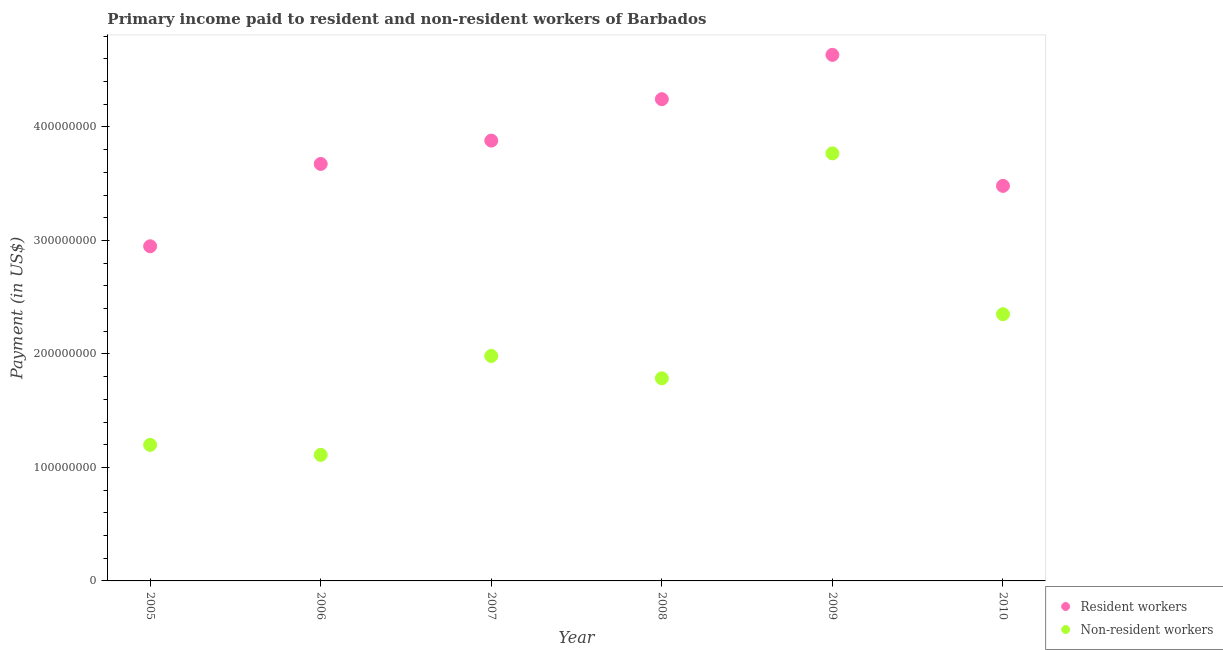What is the payment made to non-resident workers in 2005?
Offer a very short reply. 1.20e+08. Across all years, what is the maximum payment made to non-resident workers?
Your answer should be very brief. 3.77e+08. Across all years, what is the minimum payment made to non-resident workers?
Provide a succinct answer. 1.11e+08. In which year was the payment made to non-resident workers maximum?
Offer a very short reply. 2009. What is the total payment made to non-resident workers in the graph?
Offer a very short reply. 1.22e+09. What is the difference between the payment made to resident workers in 2005 and that in 2010?
Your response must be concise. -5.32e+07. What is the difference between the payment made to resident workers in 2010 and the payment made to non-resident workers in 2008?
Your answer should be very brief. 1.70e+08. What is the average payment made to non-resident workers per year?
Ensure brevity in your answer.  2.03e+08. In the year 2010, what is the difference between the payment made to non-resident workers and payment made to resident workers?
Provide a succinct answer. -1.13e+08. What is the ratio of the payment made to resident workers in 2006 to that in 2008?
Keep it short and to the point. 0.87. Is the difference between the payment made to non-resident workers in 2009 and 2010 greater than the difference between the payment made to resident workers in 2009 and 2010?
Offer a very short reply. Yes. What is the difference between the highest and the second highest payment made to non-resident workers?
Ensure brevity in your answer.  1.42e+08. What is the difference between the highest and the lowest payment made to resident workers?
Ensure brevity in your answer.  1.69e+08. In how many years, is the payment made to resident workers greater than the average payment made to resident workers taken over all years?
Your answer should be very brief. 3. Does the payment made to resident workers monotonically increase over the years?
Your response must be concise. No. Is the payment made to resident workers strictly greater than the payment made to non-resident workers over the years?
Keep it short and to the point. Yes. Is the payment made to non-resident workers strictly less than the payment made to resident workers over the years?
Keep it short and to the point. Yes. How many dotlines are there?
Your answer should be compact. 2. How many years are there in the graph?
Your response must be concise. 6. What is the difference between two consecutive major ticks on the Y-axis?
Your answer should be very brief. 1.00e+08. Does the graph contain any zero values?
Keep it short and to the point. No. Does the graph contain grids?
Your answer should be compact. No. Where does the legend appear in the graph?
Your answer should be very brief. Bottom right. What is the title of the graph?
Your response must be concise. Primary income paid to resident and non-resident workers of Barbados. Does "Male labourers" appear as one of the legend labels in the graph?
Your response must be concise. No. What is the label or title of the Y-axis?
Keep it short and to the point. Payment (in US$). What is the Payment (in US$) in Resident workers in 2005?
Provide a short and direct response. 2.95e+08. What is the Payment (in US$) in Non-resident workers in 2005?
Provide a short and direct response. 1.20e+08. What is the Payment (in US$) of Resident workers in 2006?
Ensure brevity in your answer.  3.67e+08. What is the Payment (in US$) in Non-resident workers in 2006?
Your answer should be compact. 1.11e+08. What is the Payment (in US$) in Resident workers in 2007?
Ensure brevity in your answer.  3.88e+08. What is the Payment (in US$) of Non-resident workers in 2007?
Your answer should be compact. 1.98e+08. What is the Payment (in US$) of Resident workers in 2008?
Your answer should be very brief. 4.25e+08. What is the Payment (in US$) in Non-resident workers in 2008?
Provide a short and direct response. 1.79e+08. What is the Payment (in US$) in Resident workers in 2009?
Offer a terse response. 4.64e+08. What is the Payment (in US$) in Non-resident workers in 2009?
Give a very brief answer. 3.77e+08. What is the Payment (in US$) of Resident workers in 2010?
Your response must be concise. 3.48e+08. What is the Payment (in US$) of Non-resident workers in 2010?
Give a very brief answer. 2.35e+08. Across all years, what is the maximum Payment (in US$) of Resident workers?
Keep it short and to the point. 4.64e+08. Across all years, what is the maximum Payment (in US$) of Non-resident workers?
Your answer should be compact. 3.77e+08. Across all years, what is the minimum Payment (in US$) in Resident workers?
Make the answer very short. 2.95e+08. Across all years, what is the minimum Payment (in US$) in Non-resident workers?
Provide a succinct answer. 1.11e+08. What is the total Payment (in US$) of Resident workers in the graph?
Your answer should be very brief. 2.29e+09. What is the total Payment (in US$) in Non-resident workers in the graph?
Keep it short and to the point. 1.22e+09. What is the difference between the Payment (in US$) of Resident workers in 2005 and that in 2006?
Offer a very short reply. -7.26e+07. What is the difference between the Payment (in US$) of Non-resident workers in 2005 and that in 2006?
Give a very brief answer. 8.82e+06. What is the difference between the Payment (in US$) of Resident workers in 2005 and that in 2007?
Your answer should be compact. -9.31e+07. What is the difference between the Payment (in US$) of Non-resident workers in 2005 and that in 2007?
Provide a short and direct response. -7.84e+07. What is the difference between the Payment (in US$) in Resident workers in 2005 and that in 2008?
Keep it short and to the point. -1.30e+08. What is the difference between the Payment (in US$) of Non-resident workers in 2005 and that in 2008?
Provide a short and direct response. -5.87e+07. What is the difference between the Payment (in US$) in Resident workers in 2005 and that in 2009?
Your response must be concise. -1.69e+08. What is the difference between the Payment (in US$) of Non-resident workers in 2005 and that in 2009?
Your answer should be compact. -2.57e+08. What is the difference between the Payment (in US$) in Resident workers in 2005 and that in 2010?
Offer a terse response. -5.32e+07. What is the difference between the Payment (in US$) of Non-resident workers in 2005 and that in 2010?
Offer a very short reply. -1.15e+08. What is the difference between the Payment (in US$) in Resident workers in 2006 and that in 2007?
Offer a very short reply. -2.06e+07. What is the difference between the Payment (in US$) in Non-resident workers in 2006 and that in 2007?
Ensure brevity in your answer.  -8.72e+07. What is the difference between the Payment (in US$) of Resident workers in 2006 and that in 2008?
Provide a succinct answer. -5.71e+07. What is the difference between the Payment (in US$) in Non-resident workers in 2006 and that in 2008?
Give a very brief answer. -6.75e+07. What is the difference between the Payment (in US$) of Resident workers in 2006 and that in 2009?
Your response must be concise. -9.61e+07. What is the difference between the Payment (in US$) of Non-resident workers in 2006 and that in 2009?
Make the answer very short. -2.66e+08. What is the difference between the Payment (in US$) of Resident workers in 2006 and that in 2010?
Keep it short and to the point. 1.93e+07. What is the difference between the Payment (in US$) in Non-resident workers in 2006 and that in 2010?
Your response must be concise. -1.24e+08. What is the difference between the Payment (in US$) of Resident workers in 2007 and that in 2008?
Your answer should be very brief. -3.65e+07. What is the difference between the Payment (in US$) of Non-resident workers in 2007 and that in 2008?
Your answer should be compact. 1.97e+07. What is the difference between the Payment (in US$) in Resident workers in 2007 and that in 2009?
Your answer should be very brief. -7.56e+07. What is the difference between the Payment (in US$) of Non-resident workers in 2007 and that in 2009?
Keep it short and to the point. -1.78e+08. What is the difference between the Payment (in US$) in Resident workers in 2007 and that in 2010?
Provide a short and direct response. 3.99e+07. What is the difference between the Payment (in US$) of Non-resident workers in 2007 and that in 2010?
Provide a short and direct response. -3.68e+07. What is the difference between the Payment (in US$) of Resident workers in 2008 and that in 2009?
Offer a terse response. -3.90e+07. What is the difference between the Payment (in US$) in Non-resident workers in 2008 and that in 2009?
Your answer should be very brief. -1.98e+08. What is the difference between the Payment (in US$) in Resident workers in 2008 and that in 2010?
Your response must be concise. 7.64e+07. What is the difference between the Payment (in US$) of Non-resident workers in 2008 and that in 2010?
Keep it short and to the point. -5.65e+07. What is the difference between the Payment (in US$) of Resident workers in 2009 and that in 2010?
Give a very brief answer. 1.15e+08. What is the difference between the Payment (in US$) in Non-resident workers in 2009 and that in 2010?
Make the answer very short. 1.42e+08. What is the difference between the Payment (in US$) of Resident workers in 2005 and the Payment (in US$) of Non-resident workers in 2006?
Offer a very short reply. 1.84e+08. What is the difference between the Payment (in US$) of Resident workers in 2005 and the Payment (in US$) of Non-resident workers in 2007?
Your answer should be very brief. 9.66e+07. What is the difference between the Payment (in US$) of Resident workers in 2005 and the Payment (in US$) of Non-resident workers in 2008?
Ensure brevity in your answer.  1.16e+08. What is the difference between the Payment (in US$) of Resident workers in 2005 and the Payment (in US$) of Non-resident workers in 2009?
Give a very brief answer. -8.19e+07. What is the difference between the Payment (in US$) of Resident workers in 2005 and the Payment (in US$) of Non-resident workers in 2010?
Your response must be concise. 5.99e+07. What is the difference between the Payment (in US$) of Resident workers in 2006 and the Payment (in US$) of Non-resident workers in 2007?
Keep it short and to the point. 1.69e+08. What is the difference between the Payment (in US$) in Resident workers in 2006 and the Payment (in US$) in Non-resident workers in 2008?
Ensure brevity in your answer.  1.89e+08. What is the difference between the Payment (in US$) of Resident workers in 2006 and the Payment (in US$) of Non-resident workers in 2009?
Keep it short and to the point. -9.30e+06. What is the difference between the Payment (in US$) of Resident workers in 2006 and the Payment (in US$) of Non-resident workers in 2010?
Your answer should be compact. 1.32e+08. What is the difference between the Payment (in US$) in Resident workers in 2007 and the Payment (in US$) in Non-resident workers in 2008?
Provide a succinct answer. 2.09e+08. What is the difference between the Payment (in US$) in Resident workers in 2007 and the Payment (in US$) in Non-resident workers in 2009?
Provide a succinct answer. 1.13e+07. What is the difference between the Payment (in US$) in Resident workers in 2007 and the Payment (in US$) in Non-resident workers in 2010?
Ensure brevity in your answer.  1.53e+08. What is the difference between the Payment (in US$) in Resident workers in 2008 and the Payment (in US$) in Non-resident workers in 2009?
Give a very brief answer. 4.78e+07. What is the difference between the Payment (in US$) of Resident workers in 2008 and the Payment (in US$) of Non-resident workers in 2010?
Provide a short and direct response. 1.89e+08. What is the difference between the Payment (in US$) of Resident workers in 2009 and the Payment (in US$) of Non-resident workers in 2010?
Give a very brief answer. 2.29e+08. What is the average Payment (in US$) of Resident workers per year?
Offer a terse response. 3.81e+08. What is the average Payment (in US$) of Non-resident workers per year?
Your response must be concise. 2.03e+08. In the year 2005, what is the difference between the Payment (in US$) of Resident workers and Payment (in US$) of Non-resident workers?
Your response must be concise. 1.75e+08. In the year 2006, what is the difference between the Payment (in US$) of Resident workers and Payment (in US$) of Non-resident workers?
Give a very brief answer. 2.56e+08. In the year 2007, what is the difference between the Payment (in US$) in Resident workers and Payment (in US$) in Non-resident workers?
Ensure brevity in your answer.  1.90e+08. In the year 2008, what is the difference between the Payment (in US$) in Resident workers and Payment (in US$) in Non-resident workers?
Your answer should be compact. 2.46e+08. In the year 2009, what is the difference between the Payment (in US$) in Resident workers and Payment (in US$) in Non-resident workers?
Make the answer very short. 8.68e+07. In the year 2010, what is the difference between the Payment (in US$) in Resident workers and Payment (in US$) in Non-resident workers?
Provide a succinct answer. 1.13e+08. What is the ratio of the Payment (in US$) of Resident workers in 2005 to that in 2006?
Ensure brevity in your answer.  0.8. What is the ratio of the Payment (in US$) in Non-resident workers in 2005 to that in 2006?
Offer a very short reply. 1.08. What is the ratio of the Payment (in US$) in Resident workers in 2005 to that in 2007?
Give a very brief answer. 0.76. What is the ratio of the Payment (in US$) in Non-resident workers in 2005 to that in 2007?
Offer a terse response. 0.6. What is the ratio of the Payment (in US$) of Resident workers in 2005 to that in 2008?
Make the answer very short. 0.69. What is the ratio of the Payment (in US$) in Non-resident workers in 2005 to that in 2008?
Provide a succinct answer. 0.67. What is the ratio of the Payment (in US$) in Resident workers in 2005 to that in 2009?
Your answer should be very brief. 0.64. What is the ratio of the Payment (in US$) of Non-resident workers in 2005 to that in 2009?
Provide a succinct answer. 0.32. What is the ratio of the Payment (in US$) in Resident workers in 2005 to that in 2010?
Make the answer very short. 0.85. What is the ratio of the Payment (in US$) in Non-resident workers in 2005 to that in 2010?
Your response must be concise. 0.51. What is the ratio of the Payment (in US$) of Resident workers in 2006 to that in 2007?
Your answer should be compact. 0.95. What is the ratio of the Payment (in US$) in Non-resident workers in 2006 to that in 2007?
Ensure brevity in your answer.  0.56. What is the ratio of the Payment (in US$) in Resident workers in 2006 to that in 2008?
Your answer should be compact. 0.87. What is the ratio of the Payment (in US$) in Non-resident workers in 2006 to that in 2008?
Your answer should be very brief. 0.62. What is the ratio of the Payment (in US$) in Resident workers in 2006 to that in 2009?
Ensure brevity in your answer.  0.79. What is the ratio of the Payment (in US$) of Non-resident workers in 2006 to that in 2009?
Keep it short and to the point. 0.29. What is the ratio of the Payment (in US$) of Resident workers in 2006 to that in 2010?
Your response must be concise. 1.06. What is the ratio of the Payment (in US$) of Non-resident workers in 2006 to that in 2010?
Provide a short and direct response. 0.47. What is the ratio of the Payment (in US$) of Resident workers in 2007 to that in 2008?
Your answer should be compact. 0.91. What is the ratio of the Payment (in US$) of Non-resident workers in 2007 to that in 2008?
Offer a terse response. 1.11. What is the ratio of the Payment (in US$) of Resident workers in 2007 to that in 2009?
Provide a succinct answer. 0.84. What is the ratio of the Payment (in US$) of Non-resident workers in 2007 to that in 2009?
Your answer should be compact. 0.53. What is the ratio of the Payment (in US$) in Resident workers in 2007 to that in 2010?
Your response must be concise. 1.11. What is the ratio of the Payment (in US$) in Non-resident workers in 2007 to that in 2010?
Offer a very short reply. 0.84. What is the ratio of the Payment (in US$) of Resident workers in 2008 to that in 2009?
Your answer should be very brief. 0.92. What is the ratio of the Payment (in US$) in Non-resident workers in 2008 to that in 2009?
Provide a succinct answer. 0.47. What is the ratio of the Payment (in US$) in Resident workers in 2008 to that in 2010?
Your answer should be compact. 1.22. What is the ratio of the Payment (in US$) of Non-resident workers in 2008 to that in 2010?
Your answer should be compact. 0.76. What is the ratio of the Payment (in US$) of Resident workers in 2009 to that in 2010?
Provide a succinct answer. 1.33. What is the ratio of the Payment (in US$) in Non-resident workers in 2009 to that in 2010?
Offer a terse response. 1.6. What is the difference between the highest and the second highest Payment (in US$) in Resident workers?
Your answer should be very brief. 3.90e+07. What is the difference between the highest and the second highest Payment (in US$) of Non-resident workers?
Provide a succinct answer. 1.42e+08. What is the difference between the highest and the lowest Payment (in US$) of Resident workers?
Offer a very short reply. 1.69e+08. What is the difference between the highest and the lowest Payment (in US$) of Non-resident workers?
Offer a very short reply. 2.66e+08. 